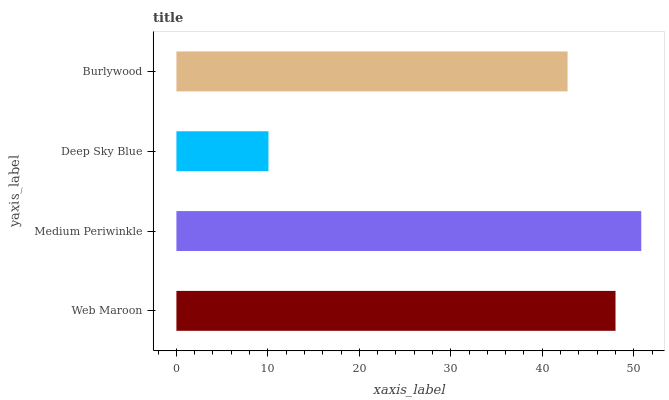Is Deep Sky Blue the minimum?
Answer yes or no. Yes. Is Medium Periwinkle the maximum?
Answer yes or no. Yes. Is Medium Periwinkle the minimum?
Answer yes or no. No. Is Deep Sky Blue the maximum?
Answer yes or no. No. Is Medium Periwinkle greater than Deep Sky Blue?
Answer yes or no. Yes. Is Deep Sky Blue less than Medium Periwinkle?
Answer yes or no. Yes. Is Deep Sky Blue greater than Medium Periwinkle?
Answer yes or no. No. Is Medium Periwinkle less than Deep Sky Blue?
Answer yes or no. No. Is Web Maroon the high median?
Answer yes or no. Yes. Is Burlywood the low median?
Answer yes or no. Yes. Is Medium Periwinkle the high median?
Answer yes or no. No. Is Web Maroon the low median?
Answer yes or no. No. 